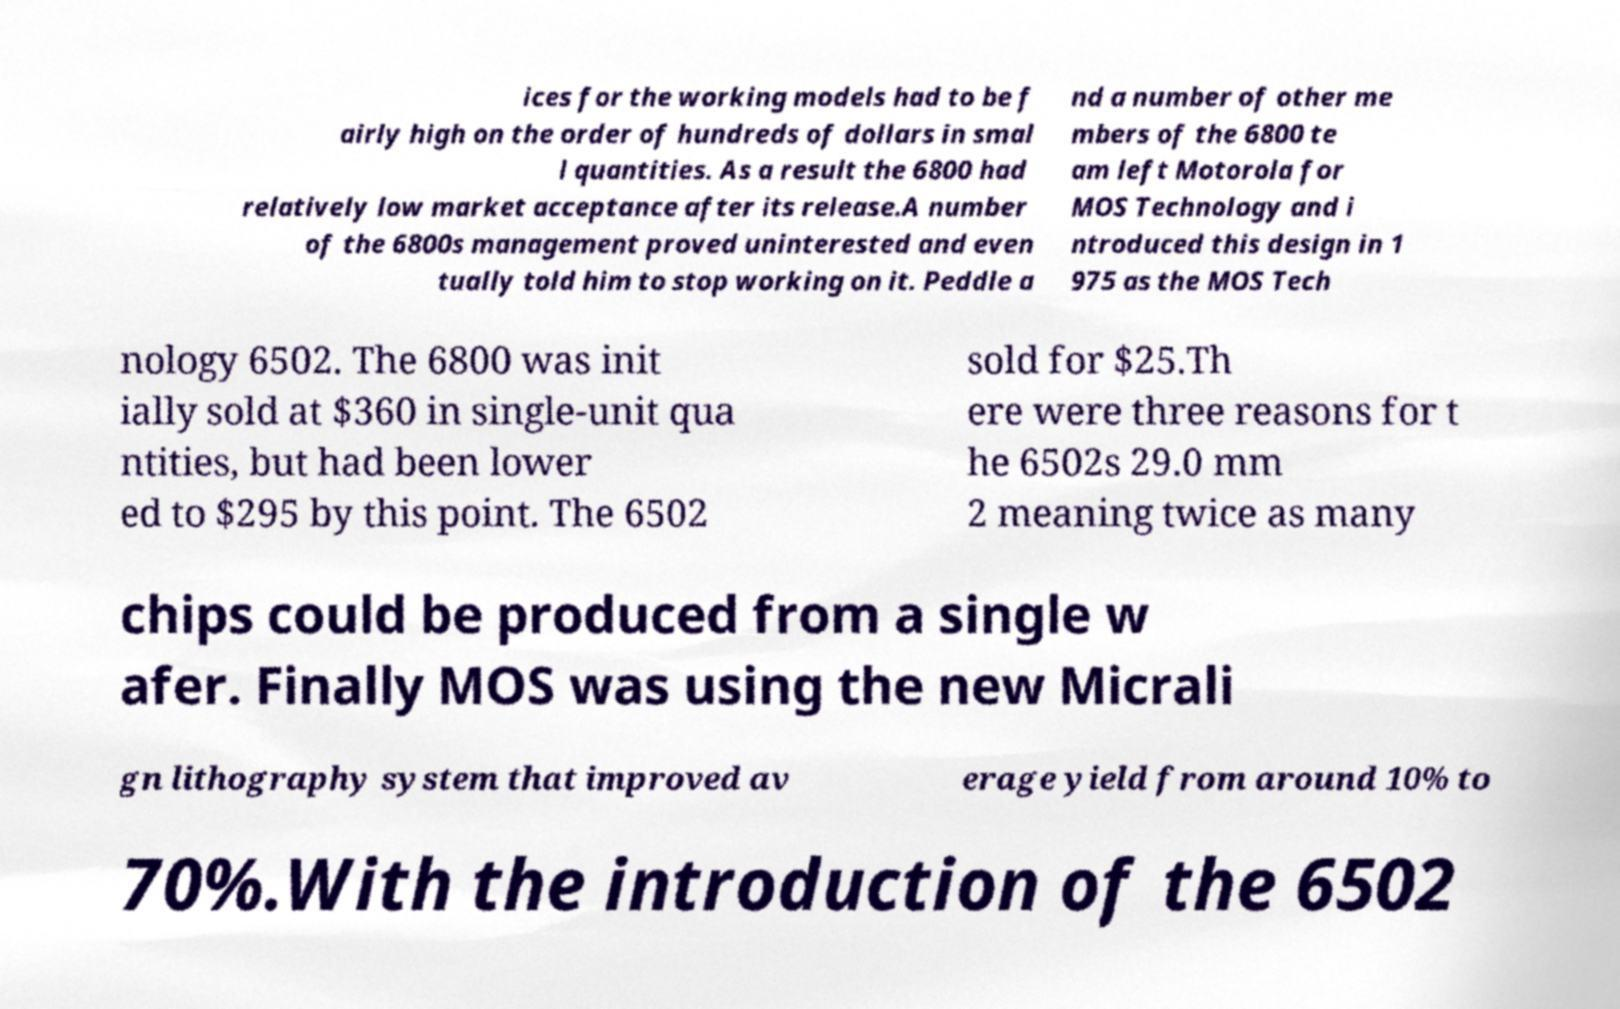For documentation purposes, I need the text within this image transcribed. Could you provide that? ices for the working models had to be f airly high on the order of hundreds of dollars in smal l quantities. As a result the 6800 had relatively low market acceptance after its release.A number of the 6800s management proved uninterested and even tually told him to stop working on it. Peddle a nd a number of other me mbers of the 6800 te am left Motorola for MOS Technology and i ntroduced this design in 1 975 as the MOS Tech nology 6502. The 6800 was init ially sold at $360 in single-unit qua ntities, but had been lower ed to $295 by this point. The 6502 sold for $25.Th ere were three reasons for t he 6502s 29.0 mm 2 meaning twice as many chips could be produced from a single w afer. Finally MOS was using the new Micrali gn lithography system that improved av erage yield from around 10% to 70%.With the introduction of the 6502 